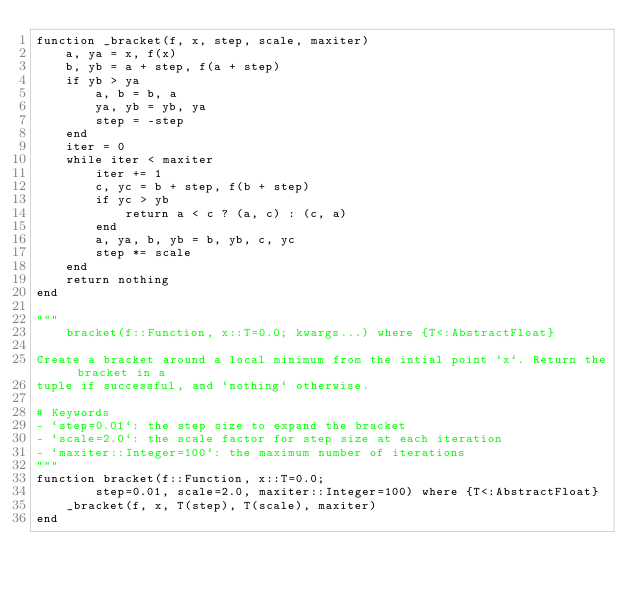<code> <loc_0><loc_0><loc_500><loc_500><_Julia_>function _bracket(f, x, step, scale, maxiter)
    a, ya = x, f(x)
    b, yb = a + step, f(a + step)
    if yb > ya
        a, b = b, a
        ya, yb = yb, ya
        step = -step
    end
    iter = 0
    while iter < maxiter
        iter += 1
        c, yc = b + step, f(b + step)
        if yc > yb
            return a < c ? (a, c) : (c, a)
        end
        a, ya, b, yb = b, yb, c, yc
        step *= scale
    end
    return nothing
end

"""
    bracket(f::Function, x::T=0.0; kwargs...) where {T<:AbstractFloat}

Create a bracket around a local minimum from the intial point `x`. Return the bracket in a 
tuple if successful, and `nothing` otherwise. 

# Keywords
- `step=0.01`: the step size to expand the bracket
- `scale=2.0`: the scale factor for step size at each iteration
- `maxiter::Integer=100`: the maximum number of iterations
"""
function bracket(f::Function, x::T=0.0; 
        step=0.01, scale=2.0, maxiter::Integer=100) where {T<:AbstractFloat}
    _bracket(f, x, T(step), T(scale), maxiter)
end</code> 